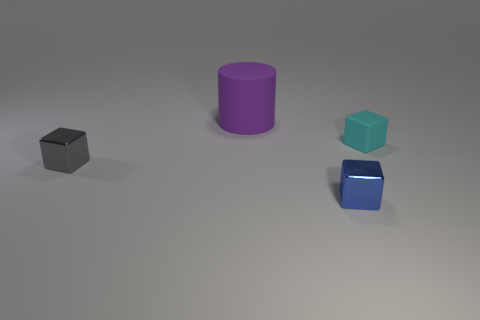What is the material of the object that is behind the cyan rubber object?
Provide a succinct answer. Rubber. How many tiny objects are red cylinders or metal objects?
Ensure brevity in your answer.  2. Are there any other tiny blocks made of the same material as the blue cube?
Keep it short and to the point. Yes. There is a rubber object that is to the left of the cyan thing; does it have the same size as the tiny cyan matte thing?
Provide a short and direct response. No. There is a thing that is to the left of the rubber object that is left of the cyan matte block; is there a small cyan matte thing in front of it?
Ensure brevity in your answer.  No. What number of rubber things are either cyan things or purple cylinders?
Ensure brevity in your answer.  2. How many other objects are there of the same shape as the purple rubber object?
Your response must be concise. 0. Are there more tiny cyan rubber blocks than small blue balls?
Ensure brevity in your answer.  Yes. There is a purple cylinder left of the tiny metal cube that is on the right side of the small metal cube that is left of the blue cube; what is its size?
Your answer should be compact. Large. What size is the matte object that is behind the tiny cyan matte cube?
Make the answer very short. Large. 